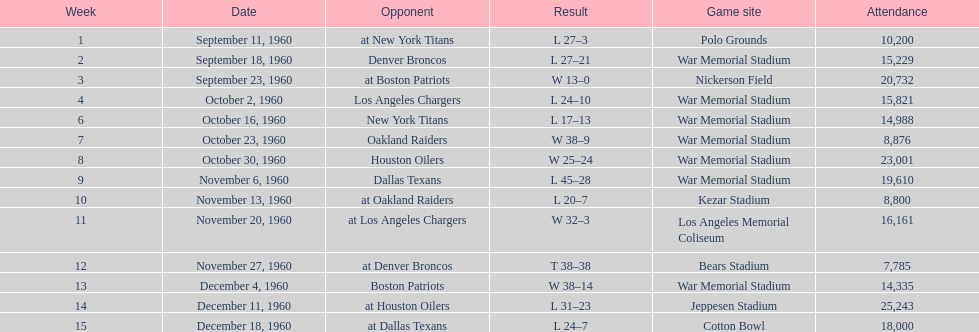Who did the bills play after the oakland raiders? Houston Oilers. 